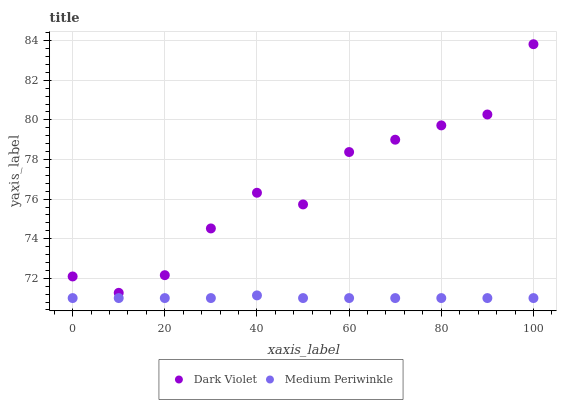Does Medium Periwinkle have the minimum area under the curve?
Answer yes or no. Yes. Does Dark Violet have the maximum area under the curve?
Answer yes or no. Yes. Does Dark Violet have the minimum area under the curve?
Answer yes or no. No. Is Medium Periwinkle the smoothest?
Answer yes or no. Yes. Is Dark Violet the roughest?
Answer yes or no. Yes. Is Dark Violet the smoothest?
Answer yes or no. No. Does Medium Periwinkle have the lowest value?
Answer yes or no. Yes. Does Dark Violet have the lowest value?
Answer yes or no. No. Does Dark Violet have the highest value?
Answer yes or no. Yes. Is Medium Periwinkle less than Dark Violet?
Answer yes or no. Yes. Is Dark Violet greater than Medium Periwinkle?
Answer yes or no. Yes. Does Medium Periwinkle intersect Dark Violet?
Answer yes or no. No. 